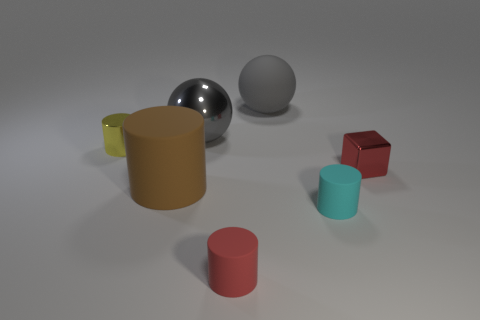How many metal objects are tiny yellow cylinders or brown cylinders?
Keep it short and to the point. 1. The gray thing that is behind the big gray sphere on the left side of the big object right of the tiny red cylinder is made of what material?
Your response must be concise. Rubber. Do the red thing in front of the big brown rubber cylinder and the small metal object that is on the right side of the yellow object have the same shape?
Make the answer very short. No. The tiny rubber cylinder that is behind the matte object that is in front of the cyan cylinder is what color?
Offer a very short reply. Cyan. How many cylinders are either big rubber things or large gray objects?
Offer a terse response. 1. What number of big metal objects are to the left of the cylinder that is on the left side of the big object on the left side of the gray shiny object?
Your response must be concise. 0. The matte cylinder that is the same color as the tiny cube is what size?
Give a very brief answer. Small. Are there any other large objects made of the same material as the big brown object?
Ensure brevity in your answer.  Yes. Do the tiny yellow thing and the red cylinder have the same material?
Keep it short and to the point. No. There is a large thing that is in front of the tiny yellow shiny object; what number of cyan cylinders are on the left side of it?
Provide a succinct answer. 0. 